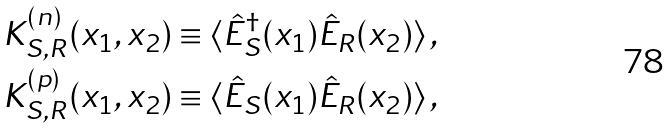Convert formula to latex. <formula><loc_0><loc_0><loc_500><loc_500>K _ { S , R } ^ { ( n ) } ( x _ { 1 } , x _ { 2 } ) & \equiv \langle \hat { E } _ { S } ^ { \dagger } ( x _ { 1 } ) \hat { E } _ { R } ( x _ { 2 } ) \rangle \, , \\ K _ { S , R } ^ { ( p ) } ( x _ { 1 } , x _ { 2 } ) & \equiv \langle \hat { E } _ { S } ( x _ { 1 } ) \hat { E } _ { R } ( x _ { 2 } ) \rangle \, ,</formula> 